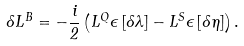<formula> <loc_0><loc_0><loc_500><loc_500>\delta L ^ { B } = - \frac { i } { 2 } \left ( L ^ { Q } \epsilon \left [ \delta \lambda \right ] - L ^ { S } \epsilon \left [ \delta \eta \right ] \right ) .</formula> 